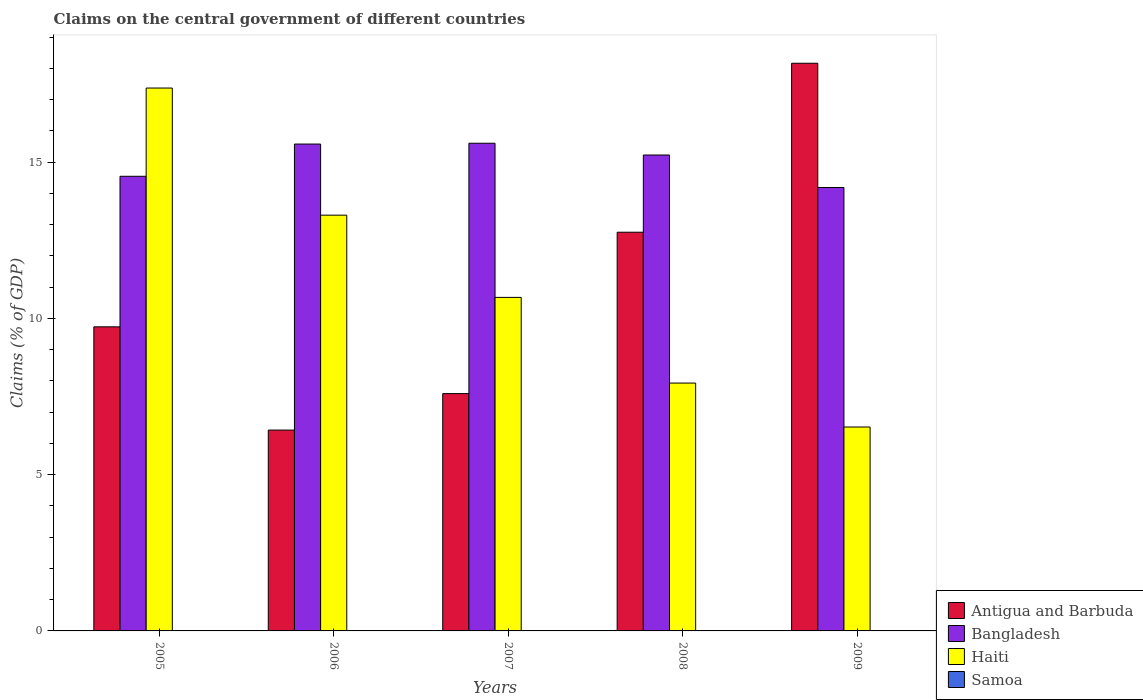Are the number of bars on each tick of the X-axis equal?
Make the answer very short. Yes. How many bars are there on the 1st tick from the right?
Keep it short and to the point. 3. In how many cases, is the number of bars for a given year not equal to the number of legend labels?
Offer a terse response. 5. What is the percentage of GDP claimed on the central government in Haiti in 2005?
Offer a terse response. 17.37. Across all years, what is the maximum percentage of GDP claimed on the central government in Haiti?
Your answer should be compact. 17.37. Across all years, what is the minimum percentage of GDP claimed on the central government in Antigua and Barbuda?
Provide a succinct answer. 6.43. What is the total percentage of GDP claimed on the central government in Bangladesh in the graph?
Offer a very short reply. 75.15. What is the difference between the percentage of GDP claimed on the central government in Haiti in 2008 and that in 2009?
Keep it short and to the point. 1.41. What is the difference between the percentage of GDP claimed on the central government in Antigua and Barbuda in 2009 and the percentage of GDP claimed on the central government in Haiti in 2006?
Offer a very short reply. 4.86. What is the average percentage of GDP claimed on the central government in Bangladesh per year?
Offer a terse response. 15.03. In the year 2006, what is the difference between the percentage of GDP claimed on the central government in Antigua and Barbuda and percentage of GDP claimed on the central government in Haiti?
Offer a very short reply. -6.88. What is the ratio of the percentage of GDP claimed on the central government in Antigua and Barbuda in 2006 to that in 2007?
Your response must be concise. 0.85. Is the difference between the percentage of GDP claimed on the central government in Antigua and Barbuda in 2005 and 2009 greater than the difference between the percentage of GDP claimed on the central government in Haiti in 2005 and 2009?
Your response must be concise. No. What is the difference between the highest and the second highest percentage of GDP claimed on the central government in Haiti?
Keep it short and to the point. 4.07. What is the difference between the highest and the lowest percentage of GDP claimed on the central government in Bangladesh?
Your answer should be compact. 1.42. What is the difference between two consecutive major ticks on the Y-axis?
Give a very brief answer. 5. Does the graph contain any zero values?
Your response must be concise. Yes. Does the graph contain grids?
Your answer should be compact. No. How are the legend labels stacked?
Your answer should be very brief. Vertical. What is the title of the graph?
Provide a short and direct response. Claims on the central government of different countries. What is the label or title of the Y-axis?
Offer a very short reply. Claims (% of GDP). What is the Claims (% of GDP) of Antigua and Barbuda in 2005?
Offer a very short reply. 9.73. What is the Claims (% of GDP) in Bangladesh in 2005?
Ensure brevity in your answer.  14.55. What is the Claims (% of GDP) of Haiti in 2005?
Offer a terse response. 17.37. What is the Claims (% of GDP) in Antigua and Barbuda in 2006?
Offer a very short reply. 6.43. What is the Claims (% of GDP) of Bangladesh in 2006?
Offer a terse response. 15.58. What is the Claims (% of GDP) of Haiti in 2006?
Offer a very short reply. 13.3. What is the Claims (% of GDP) in Antigua and Barbuda in 2007?
Ensure brevity in your answer.  7.59. What is the Claims (% of GDP) of Bangladesh in 2007?
Provide a succinct answer. 15.61. What is the Claims (% of GDP) in Haiti in 2007?
Keep it short and to the point. 10.67. What is the Claims (% of GDP) in Samoa in 2007?
Your response must be concise. 0. What is the Claims (% of GDP) of Antigua and Barbuda in 2008?
Ensure brevity in your answer.  12.76. What is the Claims (% of GDP) of Bangladesh in 2008?
Your response must be concise. 15.23. What is the Claims (% of GDP) of Haiti in 2008?
Your answer should be compact. 7.93. What is the Claims (% of GDP) in Antigua and Barbuda in 2009?
Your response must be concise. 18.17. What is the Claims (% of GDP) in Bangladesh in 2009?
Provide a succinct answer. 14.19. What is the Claims (% of GDP) in Haiti in 2009?
Ensure brevity in your answer.  6.53. Across all years, what is the maximum Claims (% of GDP) in Antigua and Barbuda?
Your response must be concise. 18.17. Across all years, what is the maximum Claims (% of GDP) of Bangladesh?
Make the answer very short. 15.61. Across all years, what is the maximum Claims (% of GDP) in Haiti?
Keep it short and to the point. 17.37. Across all years, what is the minimum Claims (% of GDP) in Antigua and Barbuda?
Keep it short and to the point. 6.43. Across all years, what is the minimum Claims (% of GDP) of Bangladesh?
Ensure brevity in your answer.  14.19. Across all years, what is the minimum Claims (% of GDP) of Haiti?
Give a very brief answer. 6.53. What is the total Claims (% of GDP) of Antigua and Barbuda in the graph?
Your answer should be compact. 54.68. What is the total Claims (% of GDP) in Bangladesh in the graph?
Your answer should be compact. 75.15. What is the total Claims (% of GDP) in Haiti in the graph?
Ensure brevity in your answer.  55.81. What is the difference between the Claims (% of GDP) in Antigua and Barbuda in 2005 and that in 2006?
Your answer should be compact. 3.3. What is the difference between the Claims (% of GDP) in Bangladesh in 2005 and that in 2006?
Provide a succinct answer. -1.03. What is the difference between the Claims (% of GDP) in Haiti in 2005 and that in 2006?
Give a very brief answer. 4.07. What is the difference between the Claims (% of GDP) of Antigua and Barbuda in 2005 and that in 2007?
Your response must be concise. 2.14. What is the difference between the Claims (% of GDP) in Bangladesh in 2005 and that in 2007?
Offer a very short reply. -1.06. What is the difference between the Claims (% of GDP) of Haiti in 2005 and that in 2007?
Your answer should be very brief. 6.7. What is the difference between the Claims (% of GDP) of Antigua and Barbuda in 2005 and that in 2008?
Your answer should be very brief. -3.03. What is the difference between the Claims (% of GDP) in Bangladesh in 2005 and that in 2008?
Give a very brief answer. -0.68. What is the difference between the Claims (% of GDP) in Haiti in 2005 and that in 2008?
Provide a succinct answer. 9.44. What is the difference between the Claims (% of GDP) of Antigua and Barbuda in 2005 and that in 2009?
Offer a terse response. -8.43. What is the difference between the Claims (% of GDP) in Bangladesh in 2005 and that in 2009?
Your answer should be compact. 0.36. What is the difference between the Claims (% of GDP) of Haiti in 2005 and that in 2009?
Make the answer very short. 10.85. What is the difference between the Claims (% of GDP) of Antigua and Barbuda in 2006 and that in 2007?
Keep it short and to the point. -1.17. What is the difference between the Claims (% of GDP) in Bangladesh in 2006 and that in 2007?
Your answer should be compact. -0.03. What is the difference between the Claims (% of GDP) in Haiti in 2006 and that in 2007?
Your answer should be compact. 2.63. What is the difference between the Claims (% of GDP) in Antigua and Barbuda in 2006 and that in 2008?
Give a very brief answer. -6.33. What is the difference between the Claims (% of GDP) of Bangladesh in 2006 and that in 2008?
Your answer should be compact. 0.35. What is the difference between the Claims (% of GDP) in Haiti in 2006 and that in 2008?
Provide a succinct answer. 5.37. What is the difference between the Claims (% of GDP) of Antigua and Barbuda in 2006 and that in 2009?
Provide a succinct answer. -11.74. What is the difference between the Claims (% of GDP) in Bangladesh in 2006 and that in 2009?
Offer a very short reply. 1.39. What is the difference between the Claims (% of GDP) of Haiti in 2006 and that in 2009?
Your answer should be very brief. 6.78. What is the difference between the Claims (% of GDP) of Antigua and Barbuda in 2007 and that in 2008?
Your response must be concise. -5.16. What is the difference between the Claims (% of GDP) in Bangladesh in 2007 and that in 2008?
Provide a short and direct response. 0.38. What is the difference between the Claims (% of GDP) in Haiti in 2007 and that in 2008?
Your answer should be compact. 2.74. What is the difference between the Claims (% of GDP) in Antigua and Barbuda in 2007 and that in 2009?
Your response must be concise. -10.57. What is the difference between the Claims (% of GDP) in Bangladesh in 2007 and that in 2009?
Ensure brevity in your answer.  1.42. What is the difference between the Claims (% of GDP) of Haiti in 2007 and that in 2009?
Provide a succinct answer. 4.15. What is the difference between the Claims (% of GDP) of Antigua and Barbuda in 2008 and that in 2009?
Ensure brevity in your answer.  -5.41. What is the difference between the Claims (% of GDP) of Bangladesh in 2008 and that in 2009?
Make the answer very short. 1.04. What is the difference between the Claims (% of GDP) in Haiti in 2008 and that in 2009?
Ensure brevity in your answer.  1.41. What is the difference between the Claims (% of GDP) of Antigua and Barbuda in 2005 and the Claims (% of GDP) of Bangladesh in 2006?
Offer a very short reply. -5.85. What is the difference between the Claims (% of GDP) of Antigua and Barbuda in 2005 and the Claims (% of GDP) of Haiti in 2006?
Your response must be concise. -3.57. What is the difference between the Claims (% of GDP) in Bangladesh in 2005 and the Claims (% of GDP) in Haiti in 2006?
Keep it short and to the point. 1.24. What is the difference between the Claims (% of GDP) in Antigua and Barbuda in 2005 and the Claims (% of GDP) in Bangladesh in 2007?
Your answer should be compact. -5.87. What is the difference between the Claims (% of GDP) in Antigua and Barbuda in 2005 and the Claims (% of GDP) in Haiti in 2007?
Keep it short and to the point. -0.94. What is the difference between the Claims (% of GDP) in Bangladesh in 2005 and the Claims (% of GDP) in Haiti in 2007?
Ensure brevity in your answer.  3.88. What is the difference between the Claims (% of GDP) of Antigua and Barbuda in 2005 and the Claims (% of GDP) of Bangladesh in 2008?
Your response must be concise. -5.5. What is the difference between the Claims (% of GDP) of Antigua and Barbuda in 2005 and the Claims (% of GDP) of Haiti in 2008?
Keep it short and to the point. 1.8. What is the difference between the Claims (% of GDP) in Bangladesh in 2005 and the Claims (% of GDP) in Haiti in 2008?
Offer a very short reply. 6.62. What is the difference between the Claims (% of GDP) of Antigua and Barbuda in 2005 and the Claims (% of GDP) of Bangladesh in 2009?
Your response must be concise. -4.46. What is the difference between the Claims (% of GDP) of Antigua and Barbuda in 2005 and the Claims (% of GDP) of Haiti in 2009?
Your response must be concise. 3.21. What is the difference between the Claims (% of GDP) of Bangladesh in 2005 and the Claims (% of GDP) of Haiti in 2009?
Your answer should be compact. 8.02. What is the difference between the Claims (% of GDP) in Antigua and Barbuda in 2006 and the Claims (% of GDP) in Bangladesh in 2007?
Provide a succinct answer. -9.18. What is the difference between the Claims (% of GDP) in Antigua and Barbuda in 2006 and the Claims (% of GDP) in Haiti in 2007?
Your answer should be very brief. -4.25. What is the difference between the Claims (% of GDP) of Bangladesh in 2006 and the Claims (% of GDP) of Haiti in 2007?
Ensure brevity in your answer.  4.91. What is the difference between the Claims (% of GDP) in Antigua and Barbuda in 2006 and the Claims (% of GDP) in Bangladesh in 2008?
Ensure brevity in your answer.  -8.8. What is the difference between the Claims (% of GDP) of Antigua and Barbuda in 2006 and the Claims (% of GDP) of Haiti in 2008?
Your answer should be compact. -1.5. What is the difference between the Claims (% of GDP) in Bangladesh in 2006 and the Claims (% of GDP) in Haiti in 2008?
Make the answer very short. 7.65. What is the difference between the Claims (% of GDP) in Antigua and Barbuda in 2006 and the Claims (% of GDP) in Bangladesh in 2009?
Your response must be concise. -7.76. What is the difference between the Claims (% of GDP) of Antigua and Barbuda in 2006 and the Claims (% of GDP) of Haiti in 2009?
Your answer should be very brief. -0.1. What is the difference between the Claims (% of GDP) of Bangladesh in 2006 and the Claims (% of GDP) of Haiti in 2009?
Make the answer very short. 9.05. What is the difference between the Claims (% of GDP) in Antigua and Barbuda in 2007 and the Claims (% of GDP) in Bangladesh in 2008?
Give a very brief answer. -7.64. What is the difference between the Claims (% of GDP) of Antigua and Barbuda in 2007 and the Claims (% of GDP) of Haiti in 2008?
Keep it short and to the point. -0.34. What is the difference between the Claims (% of GDP) in Bangladesh in 2007 and the Claims (% of GDP) in Haiti in 2008?
Give a very brief answer. 7.67. What is the difference between the Claims (% of GDP) in Antigua and Barbuda in 2007 and the Claims (% of GDP) in Bangladesh in 2009?
Your answer should be compact. -6.6. What is the difference between the Claims (% of GDP) of Antigua and Barbuda in 2007 and the Claims (% of GDP) of Haiti in 2009?
Provide a short and direct response. 1.07. What is the difference between the Claims (% of GDP) of Bangladesh in 2007 and the Claims (% of GDP) of Haiti in 2009?
Your response must be concise. 9.08. What is the difference between the Claims (% of GDP) of Antigua and Barbuda in 2008 and the Claims (% of GDP) of Bangladesh in 2009?
Give a very brief answer. -1.43. What is the difference between the Claims (% of GDP) in Antigua and Barbuda in 2008 and the Claims (% of GDP) in Haiti in 2009?
Your response must be concise. 6.23. What is the difference between the Claims (% of GDP) in Bangladesh in 2008 and the Claims (% of GDP) in Haiti in 2009?
Keep it short and to the point. 8.7. What is the average Claims (% of GDP) of Antigua and Barbuda per year?
Provide a succinct answer. 10.94. What is the average Claims (% of GDP) in Bangladesh per year?
Give a very brief answer. 15.03. What is the average Claims (% of GDP) in Haiti per year?
Your response must be concise. 11.16. What is the average Claims (% of GDP) of Samoa per year?
Make the answer very short. 0. In the year 2005, what is the difference between the Claims (% of GDP) of Antigua and Barbuda and Claims (% of GDP) of Bangladesh?
Offer a very short reply. -4.82. In the year 2005, what is the difference between the Claims (% of GDP) of Antigua and Barbuda and Claims (% of GDP) of Haiti?
Make the answer very short. -7.64. In the year 2005, what is the difference between the Claims (% of GDP) of Bangladesh and Claims (% of GDP) of Haiti?
Give a very brief answer. -2.82. In the year 2006, what is the difference between the Claims (% of GDP) in Antigua and Barbuda and Claims (% of GDP) in Bangladesh?
Your answer should be compact. -9.15. In the year 2006, what is the difference between the Claims (% of GDP) in Antigua and Barbuda and Claims (% of GDP) in Haiti?
Your answer should be very brief. -6.88. In the year 2006, what is the difference between the Claims (% of GDP) of Bangladesh and Claims (% of GDP) of Haiti?
Your response must be concise. 2.28. In the year 2007, what is the difference between the Claims (% of GDP) of Antigua and Barbuda and Claims (% of GDP) of Bangladesh?
Your answer should be compact. -8.01. In the year 2007, what is the difference between the Claims (% of GDP) in Antigua and Barbuda and Claims (% of GDP) in Haiti?
Provide a succinct answer. -3.08. In the year 2007, what is the difference between the Claims (% of GDP) in Bangladesh and Claims (% of GDP) in Haiti?
Keep it short and to the point. 4.93. In the year 2008, what is the difference between the Claims (% of GDP) of Antigua and Barbuda and Claims (% of GDP) of Bangladesh?
Ensure brevity in your answer.  -2.47. In the year 2008, what is the difference between the Claims (% of GDP) in Antigua and Barbuda and Claims (% of GDP) in Haiti?
Give a very brief answer. 4.83. In the year 2008, what is the difference between the Claims (% of GDP) in Bangladesh and Claims (% of GDP) in Haiti?
Provide a succinct answer. 7.3. In the year 2009, what is the difference between the Claims (% of GDP) in Antigua and Barbuda and Claims (% of GDP) in Bangladesh?
Your response must be concise. 3.98. In the year 2009, what is the difference between the Claims (% of GDP) of Antigua and Barbuda and Claims (% of GDP) of Haiti?
Offer a terse response. 11.64. In the year 2009, what is the difference between the Claims (% of GDP) in Bangladesh and Claims (% of GDP) in Haiti?
Provide a succinct answer. 7.66. What is the ratio of the Claims (% of GDP) in Antigua and Barbuda in 2005 to that in 2006?
Your response must be concise. 1.51. What is the ratio of the Claims (% of GDP) of Bangladesh in 2005 to that in 2006?
Provide a short and direct response. 0.93. What is the ratio of the Claims (% of GDP) of Haiti in 2005 to that in 2006?
Make the answer very short. 1.31. What is the ratio of the Claims (% of GDP) of Antigua and Barbuda in 2005 to that in 2007?
Keep it short and to the point. 1.28. What is the ratio of the Claims (% of GDP) in Bangladesh in 2005 to that in 2007?
Provide a short and direct response. 0.93. What is the ratio of the Claims (% of GDP) in Haiti in 2005 to that in 2007?
Your answer should be very brief. 1.63. What is the ratio of the Claims (% of GDP) in Antigua and Barbuda in 2005 to that in 2008?
Keep it short and to the point. 0.76. What is the ratio of the Claims (% of GDP) of Bangladesh in 2005 to that in 2008?
Your answer should be compact. 0.96. What is the ratio of the Claims (% of GDP) of Haiti in 2005 to that in 2008?
Provide a short and direct response. 2.19. What is the ratio of the Claims (% of GDP) of Antigua and Barbuda in 2005 to that in 2009?
Provide a short and direct response. 0.54. What is the ratio of the Claims (% of GDP) of Bangladesh in 2005 to that in 2009?
Give a very brief answer. 1.03. What is the ratio of the Claims (% of GDP) of Haiti in 2005 to that in 2009?
Provide a short and direct response. 2.66. What is the ratio of the Claims (% of GDP) in Antigua and Barbuda in 2006 to that in 2007?
Offer a very short reply. 0.85. What is the ratio of the Claims (% of GDP) in Haiti in 2006 to that in 2007?
Give a very brief answer. 1.25. What is the ratio of the Claims (% of GDP) of Antigua and Barbuda in 2006 to that in 2008?
Ensure brevity in your answer.  0.5. What is the ratio of the Claims (% of GDP) of Bangladesh in 2006 to that in 2008?
Provide a short and direct response. 1.02. What is the ratio of the Claims (% of GDP) in Haiti in 2006 to that in 2008?
Give a very brief answer. 1.68. What is the ratio of the Claims (% of GDP) of Antigua and Barbuda in 2006 to that in 2009?
Your answer should be compact. 0.35. What is the ratio of the Claims (% of GDP) of Bangladesh in 2006 to that in 2009?
Your answer should be very brief. 1.1. What is the ratio of the Claims (% of GDP) of Haiti in 2006 to that in 2009?
Provide a succinct answer. 2.04. What is the ratio of the Claims (% of GDP) of Antigua and Barbuda in 2007 to that in 2008?
Give a very brief answer. 0.6. What is the ratio of the Claims (% of GDP) in Bangladesh in 2007 to that in 2008?
Give a very brief answer. 1.02. What is the ratio of the Claims (% of GDP) of Haiti in 2007 to that in 2008?
Offer a very short reply. 1.35. What is the ratio of the Claims (% of GDP) of Antigua and Barbuda in 2007 to that in 2009?
Ensure brevity in your answer.  0.42. What is the ratio of the Claims (% of GDP) of Bangladesh in 2007 to that in 2009?
Ensure brevity in your answer.  1.1. What is the ratio of the Claims (% of GDP) of Haiti in 2007 to that in 2009?
Ensure brevity in your answer.  1.64. What is the ratio of the Claims (% of GDP) of Antigua and Barbuda in 2008 to that in 2009?
Your answer should be very brief. 0.7. What is the ratio of the Claims (% of GDP) of Bangladesh in 2008 to that in 2009?
Offer a very short reply. 1.07. What is the ratio of the Claims (% of GDP) of Haiti in 2008 to that in 2009?
Provide a succinct answer. 1.22. What is the difference between the highest and the second highest Claims (% of GDP) of Antigua and Barbuda?
Offer a very short reply. 5.41. What is the difference between the highest and the second highest Claims (% of GDP) of Bangladesh?
Give a very brief answer. 0.03. What is the difference between the highest and the second highest Claims (% of GDP) of Haiti?
Your response must be concise. 4.07. What is the difference between the highest and the lowest Claims (% of GDP) of Antigua and Barbuda?
Make the answer very short. 11.74. What is the difference between the highest and the lowest Claims (% of GDP) in Bangladesh?
Offer a terse response. 1.42. What is the difference between the highest and the lowest Claims (% of GDP) in Haiti?
Offer a very short reply. 10.85. 